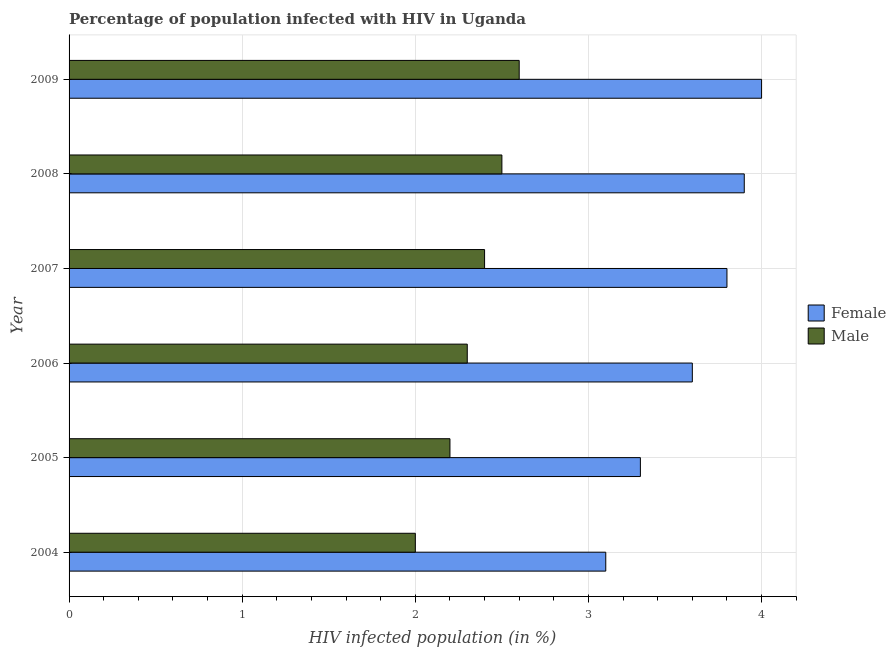Are the number of bars per tick equal to the number of legend labels?
Your response must be concise. Yes. Are the number of bars on each tick of the Y-axis equal?
Your answer should be very brief. Yes. How many bars are there on the 4th tick from the top?
Your answer should be compact. 2. In how many cases, is the number of bars for a given year not equal to the number of legend labels?
Offer a very short reply. 0. What is the percentage of males who are infected with hiv in 2008?
Make the answer very short. 2.5. Across all years, what is the maximum percentage of males who are infected with hiv?
Keep it short and to the point. 2.6. Across all years, what is the minimum percentage of females who are infected with hiv?
Keep it short and to the point. 3.1. In which year was the percentage of females who are infected with hiv maximum?
Ensure brevity in your answer.  2009. In which year was the percentage of females who are infected with hiv minimum?
Offer a very short reply. 2004. What is the total percentage of females who are infected with hiv in the graph?
Ensure brevity in your answer.  21.7. What is the difference between the percentage of males who are infected with hiv in 2004 and the percentage of females who are infected with hiv in 2005?
Provide a short and direct response. -1.3. What is the average percentage of females who are infected with hiv per year?
Ensure brevity in your answer.  3.62. In how many years, is the percentage of females who are infected with hiv greater than 1.8 %?
Give a very brief answer. 6. Is the difference between the percentage of females who are infected with hiv in 2004 and 2007 greater than the difference between the percentage of males who are infected with hiv in 2004 and 2007?
Provide a short and direct response. No. What is the difference between the highest and the second highest percentage of females who are infected with hiv?
Keep it short and to the point. 0.1. What is the difference between the highest and the lowest percentage of females who are infected with hiv?
Make the answer very short. 0.9. Is the sum of the percentage of males who are infected with hiv in 2004 and 2006 greater than the maximum percentage of females who are infected with hiv across all years?
Provide a succinct answer. Yes. What does the 2nd bar from the bottom in 2004 represents?
Your answer should be compact. Male. How many bars are there?
Your answer should be very brief. 12. Are all the bars in the graph horizontal?
Your response must be concise. Yes. How many years are there in the graph?
Make the answer very short. 6. What is the difference between two consecutive major ticks on the X-axis?
Make the answer very short. 1. Does the graph contain any zero values?
Offer a very short reply. No. How many legend labels are there?
Make the answer very short. 2. How are the legend labels stacked?
Provide a succinct answer. Vertical. What is the title of the graph?
Your answer should be compact. Percentage of population infected with HIV in Uganda. What is the label or title of the X-axis?
Your answer should be very brief. HIV infected population (in %). What is the label or title of the Y-axis?
Make the answer very short. Year. What is the HIV infected population (in %) of Female in 2005?
Your answer should be compact. 3.3. What is the HIV infected population (in %) in Male in 2005?
Give a very brief answer. 2.2. What is the HIV infected population (in %) of Female in 2006?
Offer a terse response. 3.6. What is the HIV infected population (in %) of Female in 2008?
Make the answer very short. 3.9. What is the HIV infected population (in %) of Female in 2009?
Your answer should be very brief. 4. What is the HIV infected population (in %) in Male in 2009?
Your response must be concise. 2.6. What is the total HIV infected population (in %) of Female in the graph?
Provide a short and direct response. 21.7. What is the difference between the HIV infected population (in %) in Male in 2004 and that in 2005?
Ensure brevity in your answer.  -0.2. What is the difference between the HIV infected population (in %) in Male in 2004 and that in 2006?
Keep it short and to the point. -0.3. What is the difference between the HIV infected population (in %) in Male in 2004 and that in 2007?
Ensure brevity in your answer.  -0.4. What is the difference between the HIV infected population (in %) in Male in 2004 and that in 2008?
Your response must be concise. -0.5. What is the difference between the HIV infected population (in %) of Female in 2004 and that in 2009?
Keep it short and to the point. -0.9. What is the difference between the HIV infected population (in %) in Male in 2005 and that in 2006?
Ensure brevity in your answer.  -0.1. What is the difference between the HIV infected population (in %) in Male in 2005 and that in 2008?
Your answer should be very brief. -0.3. What is the difference between the HIV infected population (in %) in Male in 2006 and that in 2007?
Provide a short and direct response. -0.1. What is the difference between the HIV infected population (in %) of Female in 2006 and that in 2008?
Offer a very short reply. -0.3. What is the difference between the HIV infected population (in %) of Male in 2006 and that in 2008?
Provide a succinct answer. -0.2. What is the difference between the HIV infected population (in %) in Female in 2006 and that in 2009?
Offer a very short reply. -0.4. What is the difference between the HIV infected population (in %) of Female in 2007 and that in 2009?
Your response must be concise. -0.2. What is the difference between the HIV infected population (in %) of Female in 2005 and the HIV infected population (in %) of Male in 2006?
Your answer should be very brief. 1. What is the difference between the HIV infected population (in %) in Female in 2005 and the HIV infected population (in %) in Male in 2007?
Your response must be concise. 0.9. What is the difference between the HIV infected population (in %) of Female in 2005 and the HIV infected population (in %) of Male in 2008?
Your answer should be compact. 0.8. What is the difference between the HIV infected population (in %) in Female in 2005 and the HIV infected population (in %) in Male in 2009?
Offer a very short reply. 0.7. What is the difference between the HIV infected population (in %) in Female in 2006 and the HIV infected population (in %) in Male in 2007?
Make the answer very short. 1.2. What is the difference between the HIV infected population (in %) in Female in 2007 and the HIV infected population (in %) in Male in 2008?
Offer a very short reply. 1.3. What is the difference between the HIV infected population (in %) in Female in 2008 and the HIV infected population (in %) in Male in 2009?
Keep it short and to the point. 1.3. What is the average HIV infected population (in %) of Female per year?
Offer a terse response. 3.62. What is the average HIV infected population (in %) in Male per year?
Offer a terse response. 2.33. In the year 2004, what is the difference between the HIV infected population (in %) of Female and HIV infected population (in %) of Male?
Offer a very short reply. 1.1. In the year 2006, what is the difference between the HIV infected population (in %) of Female and HIV infected population (in %) of Male?
Offer a very short reply. 1.3. In the year 2007, what is the difference between the HIV infected population (in %) of Female and HIV infected population (in %) of Male?
Your response must be concise. 1.4. In the year 2009, what is the difference between the HIV infected population (in %) of Female and HIV infected population (in %) of Male?
Keep it short and to the point. 1.4. What is the ratio of the HIV infected population (in %) of Female in 2004 to that in 2005?
Offer a very short reply. 0.94. What is the ratio of the HIV infected population (in %) of Male in 2004 to that in 2005?
Offer a terse response. 0.91. What is the ratio of the HIV infected population (in %) in Female in 2004 to that in 2006?
Make the answer very short. 0.86. What is the ratio of the HIV infected population (in %) of Male in 2004 to that in 2006?
Provide a short and direct response. 0.87. What is the ratio of the HIV infected population (in %) of Female in 2004 to that in 2007?
Your answer should be very brief. 0.82. What is the ratio of the HIV infected population (in %) of Female in 2004 to that in 2008?
Your answer should be compact. 0.79. What is the ratio of the HIV infected population (in %) of Female in 2004 to that in 2009?
Your response must be concise. 0.78. What is the ratio of the HIV infected population (in %) in Male in 2004 to that in 2009?
Your response must be concise. 0.77. What is the ratio of the HIV infected population (in %) of Female in 2005 to that in 2006?
Offer a terse response. 0.92. What is the ratio of the HIV infected population (in %) of Male in 2005 to that in 2006?
Make the answer very short. 0.96. What is the ratio of the HIV infected population (in %) of Female in 2005 to that in 2007?
Give a very brief answer. 0.87. What is the ratio of the HIV infected population (in %) in Female in 2005 to that in 2008?
Your response must be concise. 0.85. What is the ratio of the HIV infected population (in %) of Female in 2005 to that in 2009?
Ensure brevity in your answer.  0.82. What is the ratio of the HIV infected population (in %) in Male in 2005 to that in 2009?
Keep it short and to the point. 0.85. What is the ratio of the HIV infected population (in %) in Female in 2006 to that in 2007?
Make the answer very short. 0.95. What is the ratio of the HIV infected population (in %) of Male in 2006 to that in 2007?
Make the answer very short. 0.96. What is the ratio of the HIV infected population (in %) in Male in 2006 to that in 2008?
Provide a short and direct response. 0.92. What is the ratio of the HIV infected population (in %) of Male in 2006 to that in 2009?
Offer a very short reply. 0.88. What is the ratio of the HIV infected population (in %) of Female in 2007 to that in 2008?
Make the answer very short. 0.97. What is the ratio of the HIV infected population (in %) in Male in 2007 to that in 2008?
Your answer should be very brief. 0.96. What is the ratio of the HIV infected population (in %) of Female in 2007 to that in 2009?
Ensure brevity in your answer.  0.95. What is the ratio of the HIV infected population (in %) of Male in 2007 to that in 2009?
Provide a short and direct response. 0.92. What is the ratio of the HIV infected population (in %) of Male in 2008 to that in 2009?
Your response must be concise. 0.96. What is the difference between the highest and the second highest HIV infected population (in %) of Female?
Your response must be concise. 0.1. What is the difference between the highest and the lowest HIV infected population (in %) of Male?
Your response must be concise. 0.6. 